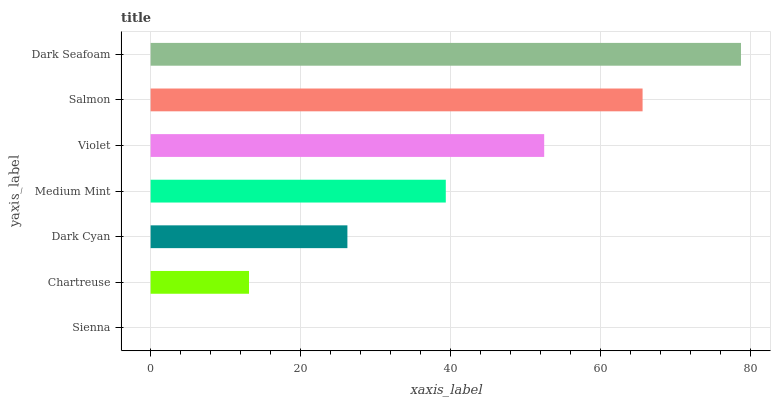Is Sienna the minimum?
Answer yes or no. Yes. Is Dark Seafoam the maximum?
Answer yes or no. Yes. Is Chartreuse the minimum?
Answer yes or no. No. Is Chartreuse the maximum?
Answer yes or no. No. Is Chartreuse greater than Sienna?
Answer yes or no. Yes. Is Sienna less than Chartreuse?
Answer yes or no. Yes. Is Sienna greater than Chartreuse?
Answer yes or no. No. Is Chartreuse less than Sienna?
Answer yes or no. No. Is Medium Mint the high median?
Answer yes or no. Yes. Is Medium Mint the low median?
Answer yes or no. Yes. Is Dark Seafoam the high median?
Answer yes or no. No. Is Violet the low median?
Answer yes or no. No. 